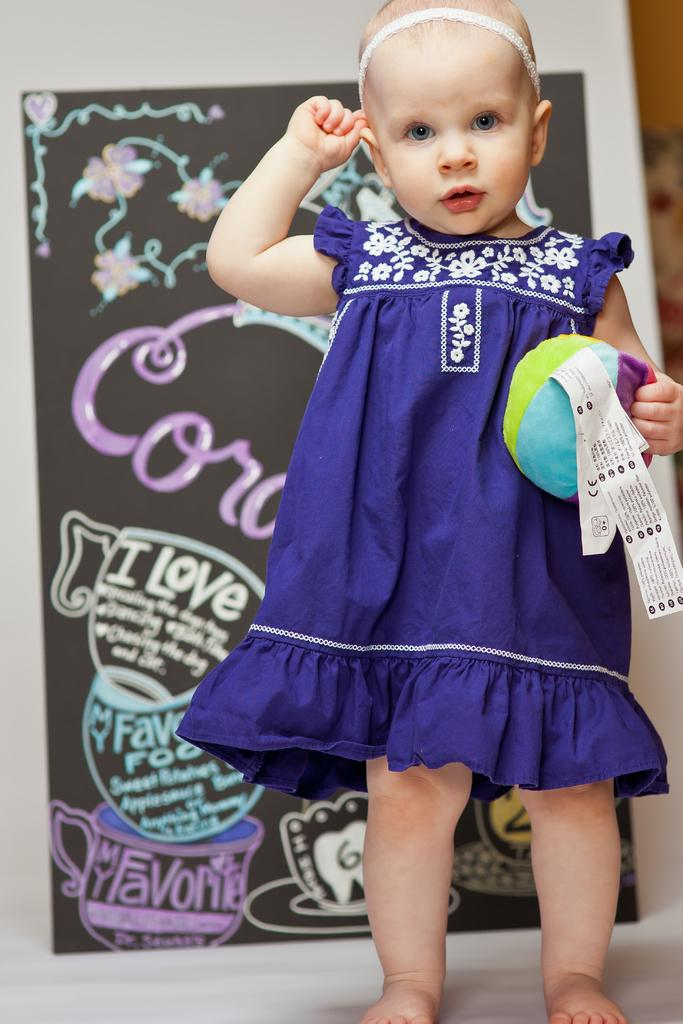What is the main subject of the image? The main subject of the image is a kid. What is the kid holding in the image? The kid is holding an object. What can be seen beneath the kid in the image? The ground is visible in the image. What is present in the background of the image? There is a background with a poster in the image. How many trees can be seen in the image? There are no trees visible in the image. Can you describe the kiss between the two characters in the image? There are no characters or kisses present in the image; it features a kid holding an object. 